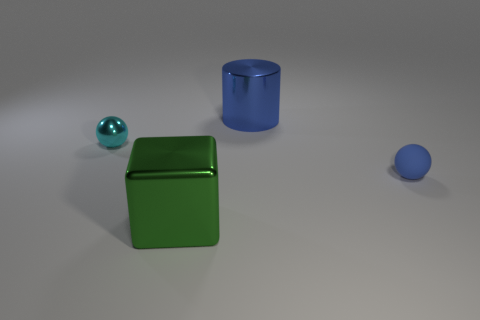Are there any other things that have the same material as the blue ball?
Provide a short and direct response. No. How big is the object to the right of the object that is behind the small thing to the left of the blue cylinder?
Offer a terse response. Small. Does the blue metallic thing have the same shape as the blue object that is on the right side of the big metal cylinder?
Provide a succinct answer. No. How many other things are the same size as the matte object?
Offer a very short reply. 1. How big is the metal thing on the left side of the green metal block?
Provide a short and direct response. Small. What number of small blue objects are made of the same material as the green object?
Give a very brief answer. 0. There is a cyan thing to the left of the large shiny cylinder; is its shape the same as the large blue object?
Make the answer very short. No. There is a blue thing in front of the metallic cylinder; what shape is it?
Offer a very short reply. Sphere. What is the size of the sphere that is the same color as the metal cylinder?
Your response must be concise. Small. What is the green thing made of?
Your response must be concise. Metal. 